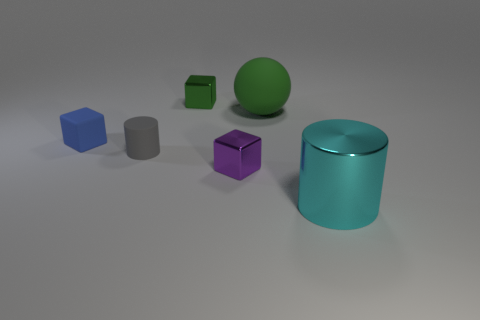Can you describe the lighting and shadows in the scene? The scene is lit from a direction that's not visible in the image, casting soft shadows to the right of each object. The shadows are somewhat diffuse, indicating the light source is not too close to the objects. This diffuse shadowing contributes to the overall calm and balanced ambiance of the scene. 